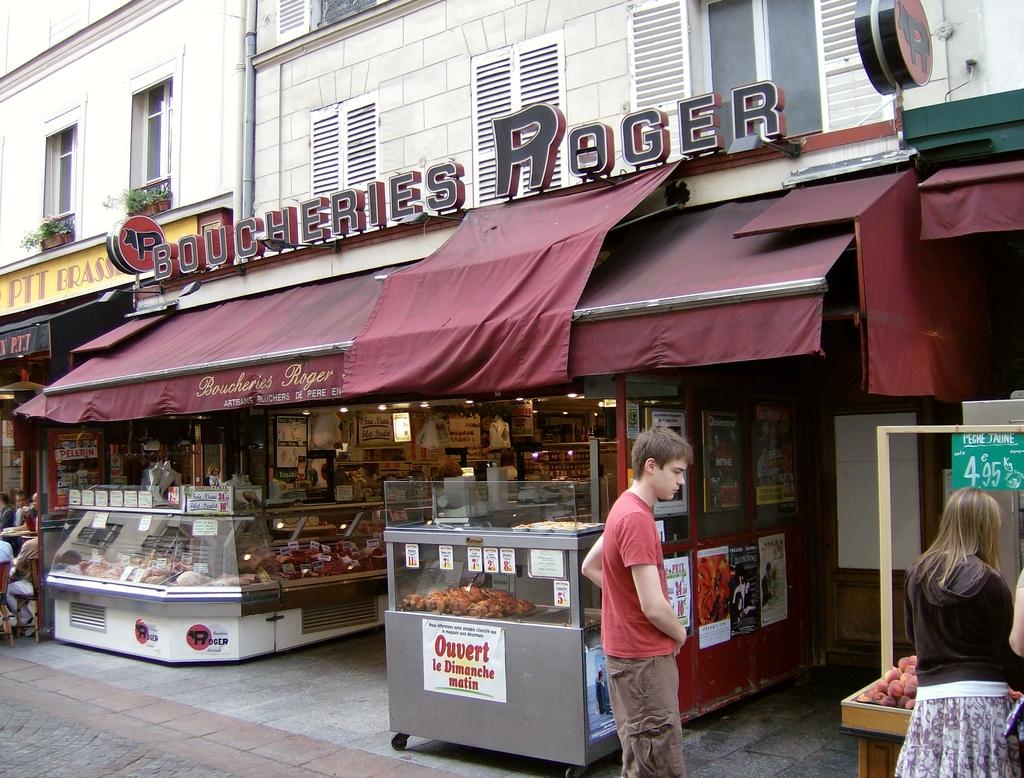What is the stand behind the man selling?
Your response must be concise. Ouvert. What's the name of the shop?
Offer a very short reply. Boucheries roger. 